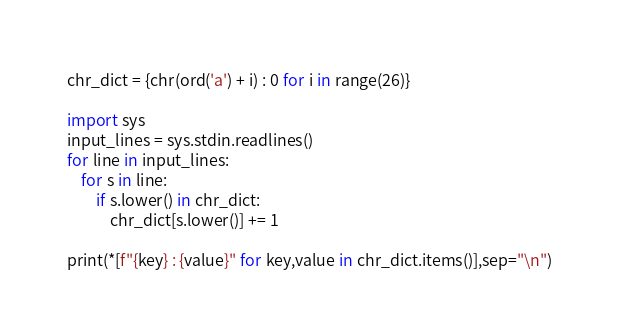<code> <loc_0><loc_0><loc_500><loc_500><_Python_>chr_dict = {chr(ord('a') + i) : 0 for i in range(26)}

import sys
input_lines = sys.stdin.readlines()
for line in input_lines:
    for s in line:
        if s.lower() in chr_dict:
            chr_dict[s.lower()] += 1

print(*[f"{key} : {value}" for key,value in chr_dict.items()],sep="\n")
</code> 